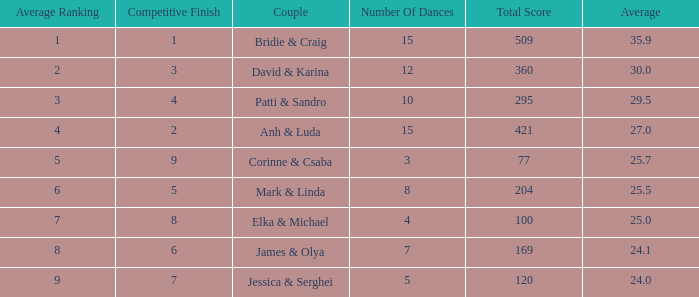What is the average for the couple anh & luda? 27.0. 